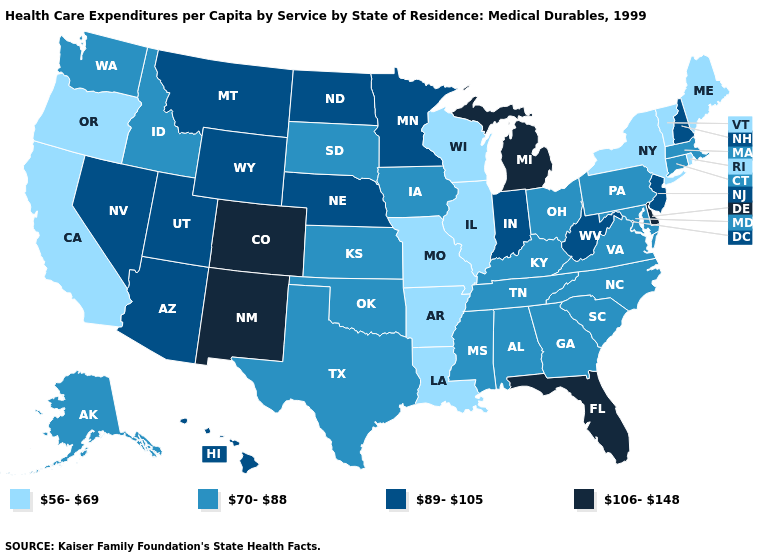How many symbols are there in the legend?
Answer briefly. 4. What is the value of Michigan?
Write a very short answer. 106-148. Does Illinois have the lowest value in the USA?
Be succinct. Yes. What is the highest value in the USA?
Write a very short answer. 106-148. What is the lowest value in the USA?
Give a very brief answer. 56-69. What is the value of Ohio?
Keep it brief. 70-88. What is the value of Idaho?
Concise answer only. 70-88. What is the lowest value in the USA?
Answer briefly. 56-69. Name the states that have a value in the range 70-88?
Write a very short answer. Alabama, Alaska, Connecticut, Georgia, Idaho, Iowa, Kansas, Kentucky, Maryland, Massachusetts, Mississippi, North Carolina, Ohio, Oklahoma, Pennsylvania, South Carolina, South Dakota, Tennessee, Texas, Virginia, Washington. Name the states that have a value in the range 89-105?
Write a very short answer. Arizona, Hawaii, Indiana, Minnesota, Montana, Nebraska, Nevada, New Hampshire, New Jersey, North Dakota, Utah, West Virginia, Wyoming. What is the value of Indiana?
Quick response, please. 89-105. Name the states that have a value in the range 56-69?
Short answer required. Arkansas, California, Illinois, Louisiana, Maine, Missouri, New York, Oregon, Rhode Island, Vermont, Wisconsin. Among the states that border Iowa , which have the lowest value?
Write a very short answer. Illinois, Missouri, Wisconsin. What is the highest value in the USA?
Quick response, please. 106-148. 